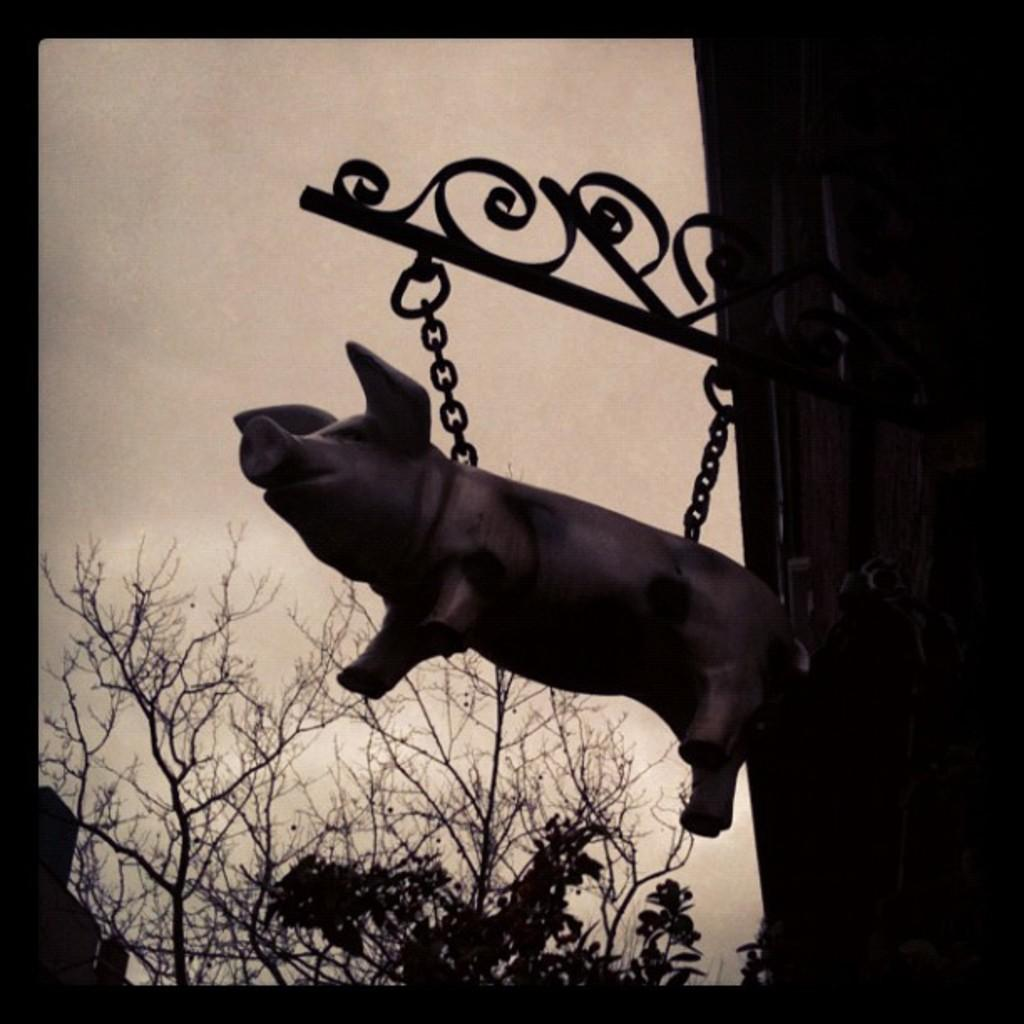What is the main subject of the image? There is a sculpture of a pig in the image. What is unique about the sculpture? The sculpture has chains in the front. What can be seen in the background of the image? There are trees in the background of the image. What is visible at the top of the image? The sky is visible at the top of the image. What is the tendency of the arm in the image? There is no arm present in the image; it features a sculpture of a pig with chains in the front. How does the porter assist in the image? There is no porter present in the image; it features a sculpture of a pig with chains in the front. 